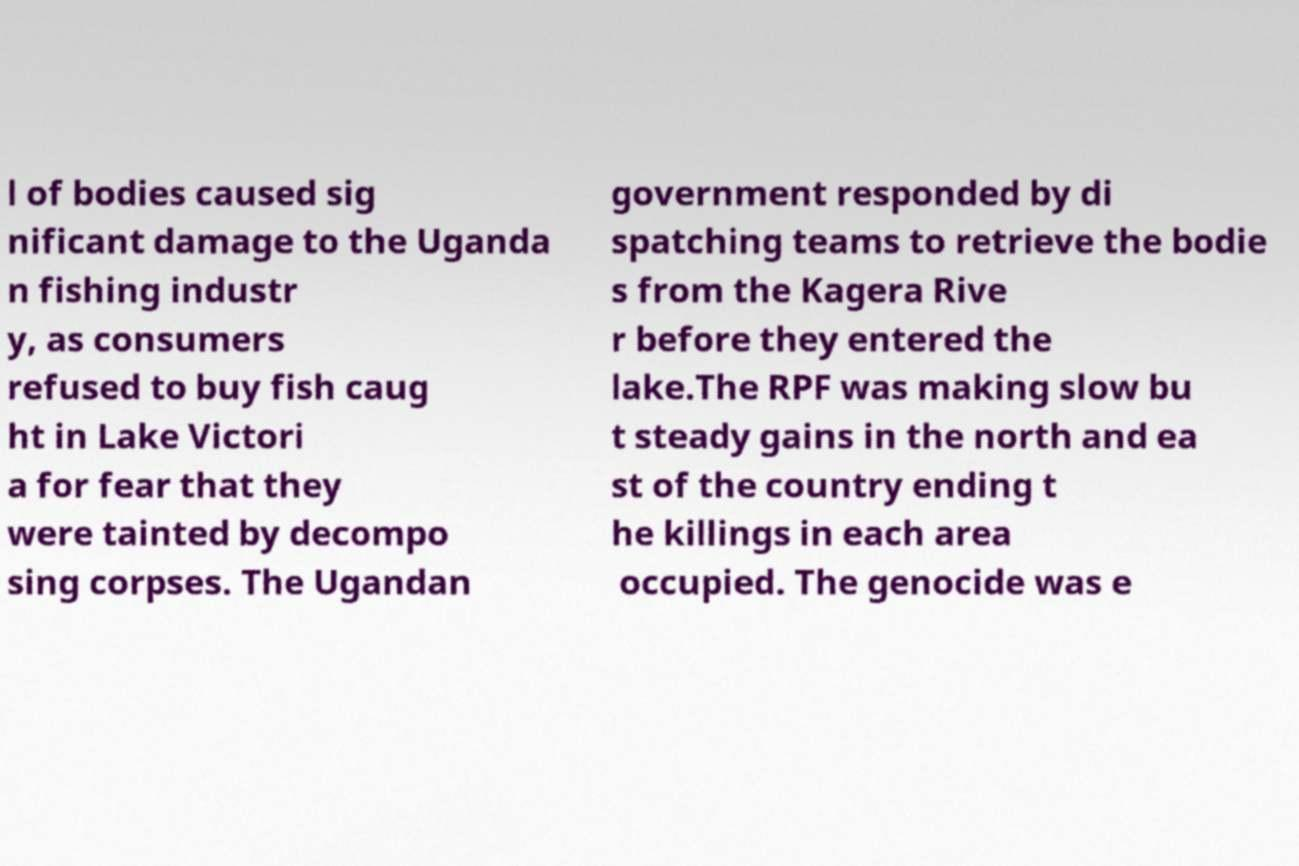Please read and relay the text visible in this image. What does it say? l of bodies caused sig nificant damage to the Uganda n fishing industr y, as consumers refused to buy fish caug ht in Lake Victori a for fear that they were tainted by decompo sing corpses. The Ugandan government responded by di spatching teams to retrieve the bodie s from the Kagera Rive r before they entered the lake.The RPF was making slow bu t steady gains in the north and ea st of the country ending t he killings in each area occupied. The genocide was e 